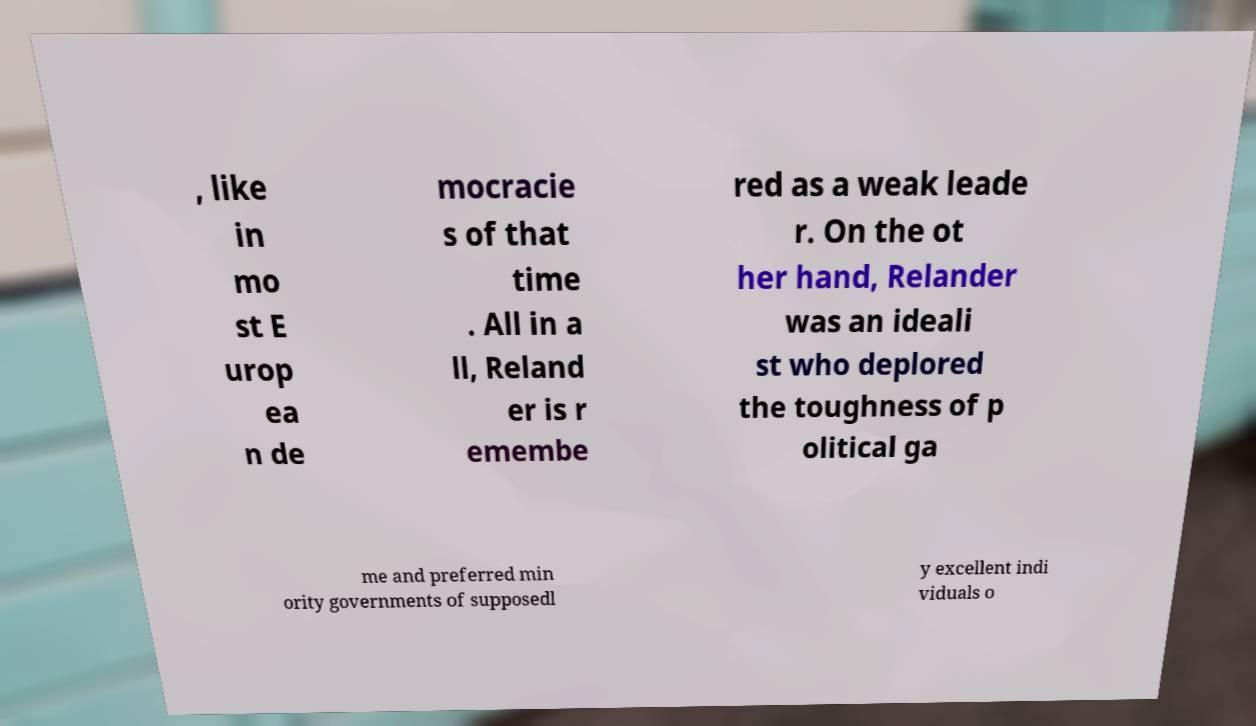For documentation purposes, I need the text within this image transcribed. Could you provide that? , like in mo st E urop ea n de mocracie s of that time . All in a ll, Reland er is r emembe red as a weak leade r. On the ot her hand, Relander was an ideali st who deplored the toughness of p olitical ga me and preferred min ority governments of supposedl y excellent indi viduals o 